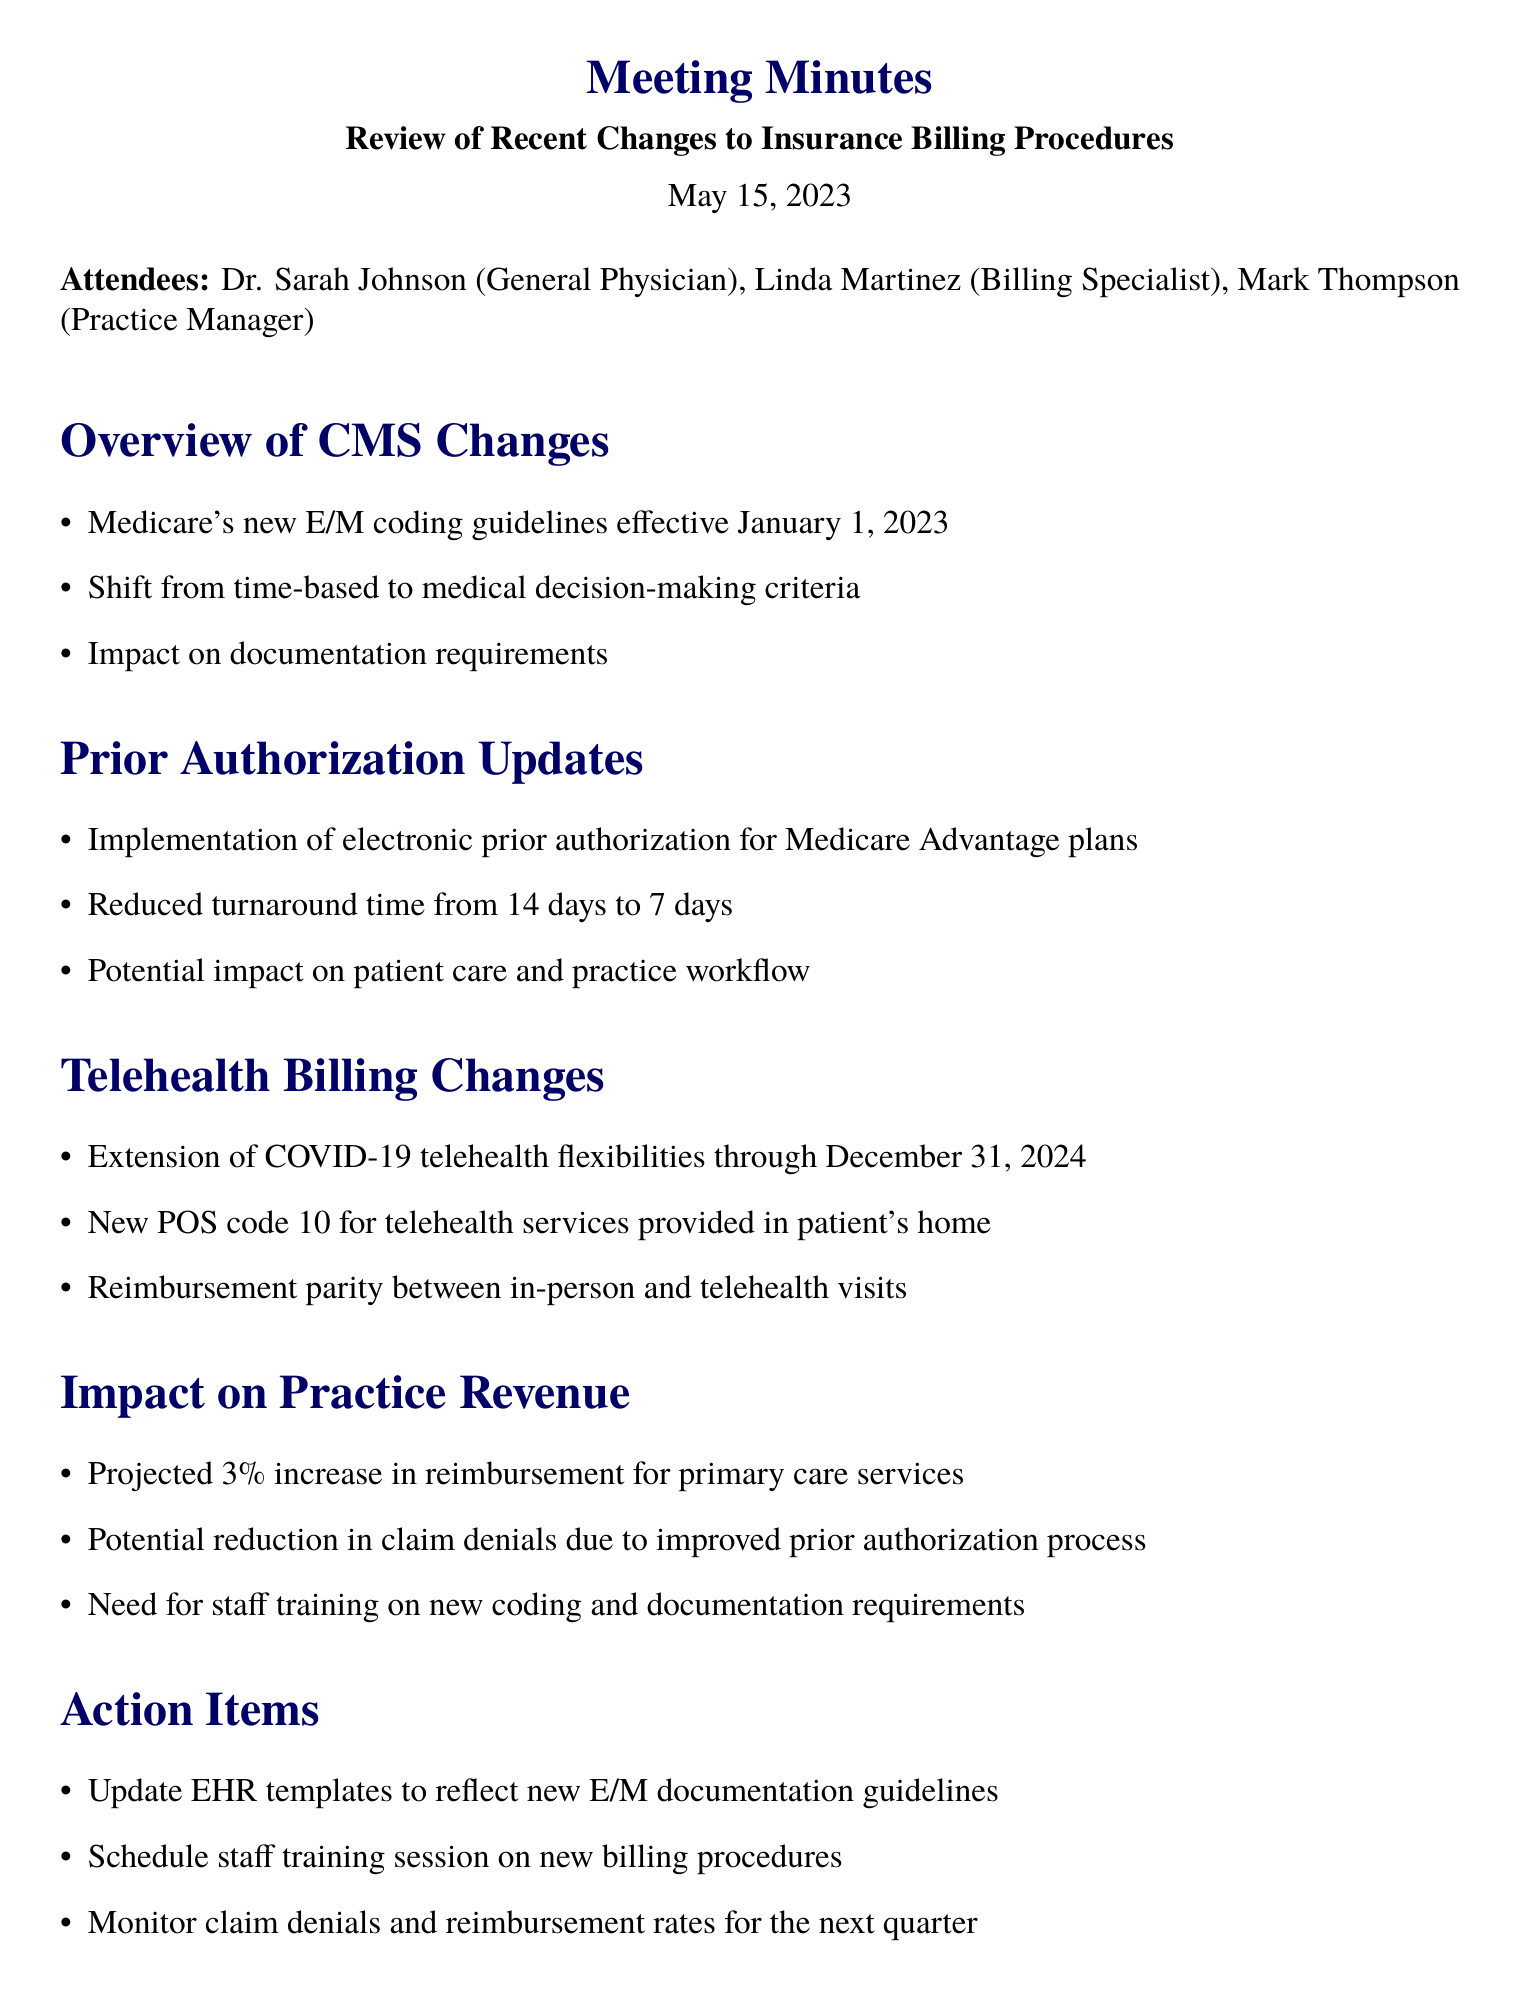What is the date of the meeting? The date of the meeting is mentioned at the beginning of the document.
Answer: May 15, 2023 Who is the general physician in attendance? The document lists the attendees, specifying their roles.
Answer: Dr. Sarah Johnson What is the projected increase in reimbursement for primary care services? The document provides projected revenue impacts under the "Impact on Practice Revenue" section.
Answer: 3% What new coding guidelines became effective on January 1, 2023? The document outlines the changes under "Overview of CMS Changes."
Answer: E/M coding guidelines What is the new turnaround time for prior authorizations? The turnaround time reduction is stated in the "Prior Authorization Updates" section.
Answer: 7 days What action item involves updating EHR templates? The document lists action items that require follow-up steps after the meeting.
Answer: Update EHR templates to reflect new E/M documentation guidelines What is the extension period for COVID-19 telehealth flexibilities? The length of the extension can be found in the "Telehealth Billing Changes" section.
Answer: Through December 31, 2024 What is one potential benefit of the improved prior authorization process? The "Impact on Practice Revenue" section discusses benefits related to claim denials.
Answer: Reduction in claim denials 